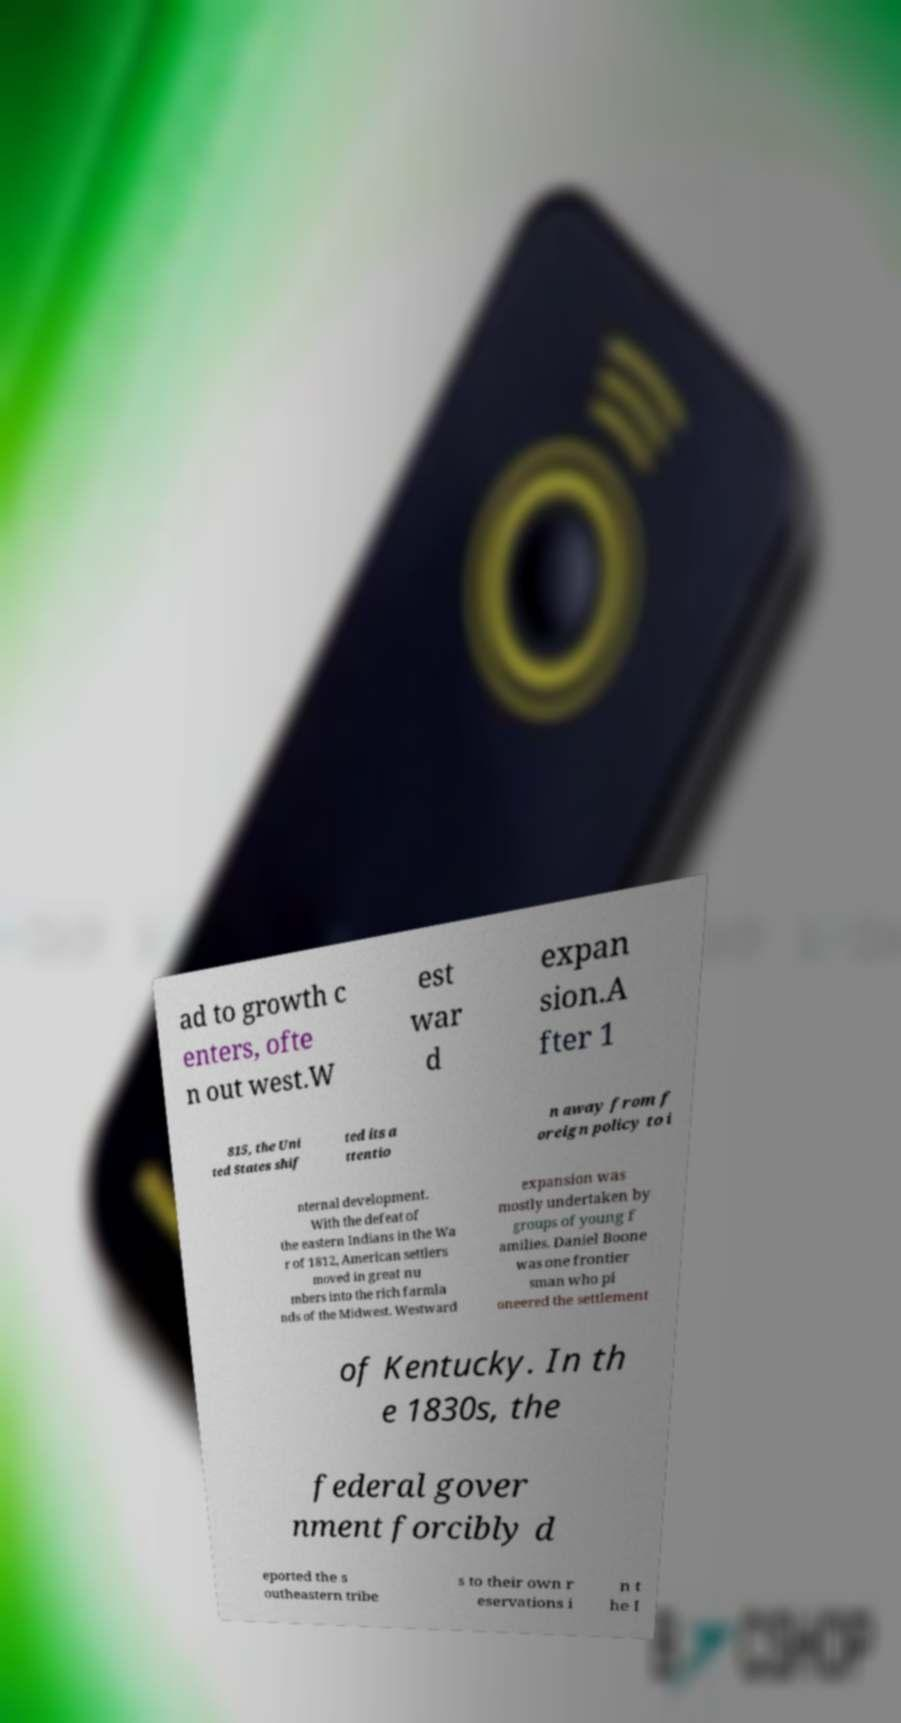Can you accurately transcribe the text from the provided image for me? ad to growth c enters, ofte n out west.W est war d expan sion.A fter 1 815, the Uni ted States shif ted its a ttentio n away from f oreign policy to i nternal development. With the defeat of the eastern Indians in the Wa r of 1812, American settlers moved in great nu mbers into the rich farmla nds of the Midwest. Westward expansion was mostly undertaken by groups of young f amilies. Daniel Boone was one frontier sman who pi oneered the settlement of Kentucky. In th e 1830s, the federal gover nment forcibly d eported the s outheastern tribe s to their own r eservations i n t he I 